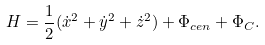Convert formula to latex. <formula><loc_0><loc_0><loc_500><loc_500>H = \frac { 1 } { 2 } ( \dot { x } ^ { 2 } + \dot { y } ^ { 2 } + \dot { z } ^ { 2 } ) + \Phi _ { c e n } + \Phi _ { C } .</formula> 